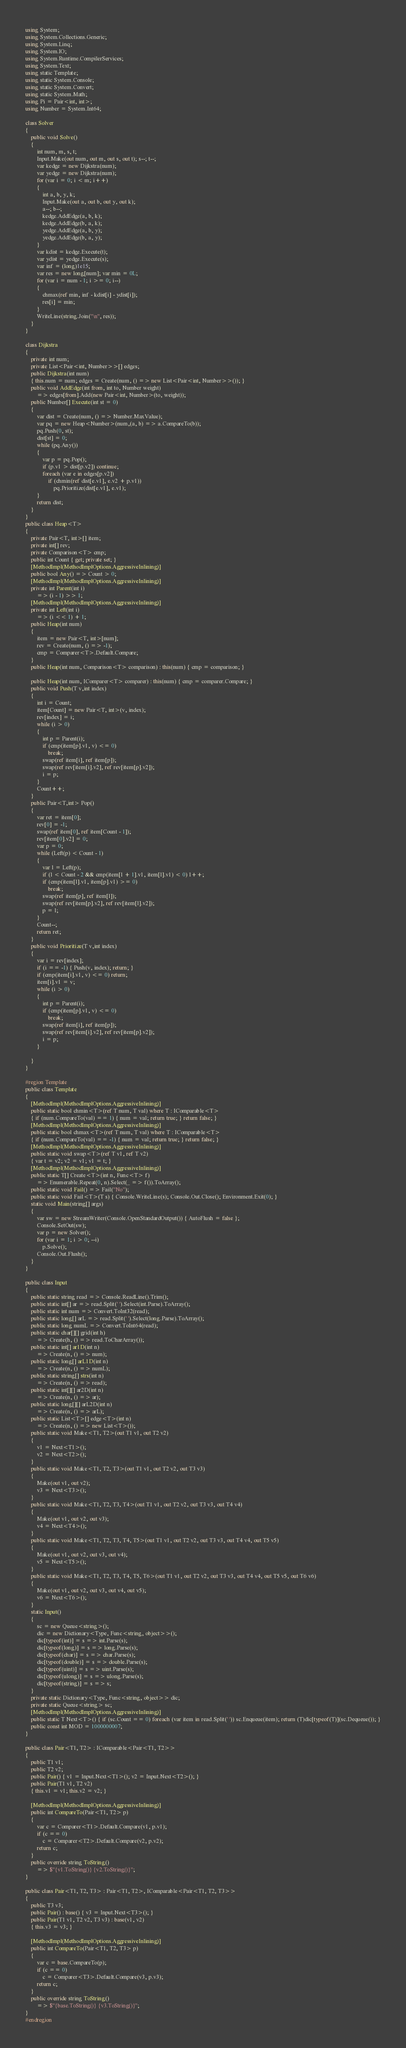<code> <loc_0><loc_0><loc_500><loc_500><_C#_>using System;
using System.Collections.Generic;
using System.Linq;
using System.IO;
using System.Runtime.CompilerServices;
using System.Text;
using static Template;
using static System.Console;
using static System.Convert;
using static System.Math;
using Pi = Pair<int, int>;
using Number = System.Int64;

class Solver
{
    public void Solve()
    {
        int num, m, s, t;
        Input.Make(out num, out m, out s, out t); s--; t--;
        var kedge = new Dijkstra(num);
        var yedge = new Dijkstra(num);
        for (var i = 0; i < m; i++)
        {
            int a, b, y, k;
            Input.Make(out a, out b, out y, out k);
            a--; b--;
            kedge.AddEdge(a, b, k);
            kedge.AddEdge(b, a, k);
            yedge.AddEdge(a, b, y);
            yedge.AddEdge(b, a, y);
        }
        var kdist = kedge.Execute(t);
        var ydist = yedge.Execute(s);
        var inf = (long)1e15;
        var res = new long[num]; var min = 0L;
        for (var i = num - 1; i >= 0; i--)
        {
            chmax(ref min, inf - kdist[i] - ydist[i]);
            res[i] = min;
        }
        WriteLine(string.Join("\n", res));
    }
}

class Dijkstra
{
    private int num;
    private List<Pair<int, Number>>[] edges;
    public Dijkstra(int num)
    { this.num = num; edges = Create(num, () => new List<Pair<int, Number>>()); }
    public void AddEdge(int from, int to, Number weight)
        => edges[from].Add(new Pair<int, Number>(to, weight));
    public Number[] Execute(int st = 0)
    {
        var dist = Create(num, () => Number.MaxValue);
        var pq = new Heap<Number>(num,(a, b) => a.CompareTo(b));
        pq.Push(0, st);
        dist[st] = 0;
        while (pq.Any())
        {
            var p = pq.Pop();
            if (p.v1 > dist[p.v2]) continue;
            foreach (var e in edges[p.v2])
                if (chmin(ref dist[e.v1], e.v2 + p.v1))
                    pq.Prioritize(dist[e.v1], e.v1);
        }
        return dist;
    }
}
public class Heap<T>
{
    private Pair<T, int>[] item;
    private int[] rev;
    private Comparison<T> cmp;
    public int Count { get; private set; }
    [MethodImpl(MethodImplOptions.AggressiveInlining)]
    public bool Any() => Count > 0;
    [MethodImpl(MethodImplOptions.AggressiveInlining)]
    private int Parent(int i)
        => (i - 1) >> 1;
    [MethodImpl(MethodImplOptions.AggressiveInlining)]
    private int Left(int i)
        => (i << 1) + 1;
    public Heap(int num)
    {
        item = new Pair<T, int>[num];
        rev = Create(num, () => -1);
        cmp = Comparer<T>.Default.Compare;
    }
    public Heap(int num, Comparison<T> comparison) : this(num) { cmp = comparison; }

    public Heap(int num, IComparer<T> comparer) : this(num) { cmp = comparer.Compare; }
    public void Push(T v,int index)
    {
        int i = Count;
        item[Count] = new Pair<T, int>(v, index);
        rev[index] = i;
        while (i > 0)
        {
            int p = Parent(i);
            if (cmp(item[p].v1, v) <= 0)
                break;
            swap(ref item[i], ref item[p]);
            swap(ref rev[item[i].v2], ref rev[item[p].v2]);
            i = p;
        }
        Count++;
    }
    public Pair<T,int> Pop()
    {
        var ret = item[0];
        rev[0] = -1;
        swap(ref item[0], ref item[Count - 1]);
        rev[item[0].v2] = 0;
        var p = 0;
        while (Left(p) < Count - 1)
        {
            var l = Left(p);
            if (l < Count - 2 && cmp(item[l + 1].v1, item[l].v1) < 0) l++;
            if (cmp(item[l].v1, item[p].v1) >= 0)
                break;
            swap(ref item[p], ref item[l]);
            swap(ref rev[item[p].v2], ref rev[item[l].v2]);
            p = l;
        }
        Count--;
        return ret;
    }
    public void Prioritize(T v,int index)
    {
        var i = rev[index];
        if (i == -1) { Push(v, index); return; }
        if (cmp(item[i].v1, v) <= 0) return;
        item[i].v1 = v;
        while (i > 0)
        {
            int p = Parent(i);
            if (cmp(item[p].v1, v) <= 0)
                break;
            swap(ref item[i], ref item[p]);
            swap(ref rev[item[i].v2], ref rev[item[p].v2]);
            i = p;
        }

    }
}

#region Template
public class Template
{
    [MethodImpl(MethodImplOptions.AggressiveInlining)]
    public static bool chmin<T>(ref T num, T val) where T : IComparable<T>
    { if (num.CompareTo(val) == 1) { num = val; return true; } return false; }
    [MethodImpl(MethodImplOptions.AggressiveInlining)]
    public static bool chmax<T>(ref T num, T val) where T : IComparable<T>
    { if (num.CompareTo(val) == -1) { num = val; return true; } return false; }
    [MethodImpl(MethodImplOptions.AggressiveInlining)]
    public static void swap<T>(ref T v1, ref T v2)
    { var t = v2; v2 = v1; v1 = t; }
    [MethodImpl(MethodImplOptions.AggressiveInlining)]
    public static T[] Create<T>(int n, Func<T> f)
        => Enumerable.Repeat(0, n).Select(_ => f()).ToArray();
    public static void Fail() => Fail("No");
    public static void Fail<T>(T s) { Console.WriteLine(s); Console.Out.Close(); Environment.Exit(0); }
    static void Main(string[] args)
    {
        var sw = new StreamWriter(Console.OpenStandardOutput()) { AutoFlush = false };
        Console.SetOut(sw);
        var p = new Solver();
        for (var i = 1; i > 0; --i)
            p.Solve();
        Console.Out.Flush();
    }
}

public class Input
{
    public static string read => Console.ReadLine().Trim();
    public static int[] ar => read.Split(' ').Select(int.Parse).ToArray();
    public static int num => Convert.ToInt32(read);
    public static long[] arL => read.Split(' ').Select(long.Parse).ToArray();
    public static long numL => Convert.ToInt64(read);
    public static char[][] grid(int h)
        => Create(h, () => read.ToCharArray());
    public static int[] ar1D(int n)
        => Create(n, () => num);
    public static long[] arL1D(int n)
        => Create(n, () => numL);
    public static string[] strs(int n)
        => Create(n, () => read);
    public static int[][] ar2D(int n)
        => Create(n, () => ar);
    public static long[][] arL2D(int n)
        => Create(n, () => arL);
    public static List<T>[] edge<T>(int n)
        => Create(n, () => new List<T>());
    public static void Make<T1, T2>(out T1 v1, out T2 v2)
    {
        v1 = Next<T1>();
        v2 = Next<T2>();
    }
    public static void Make<T1, T2, T3>(out T1 v1, out T2 v2, out T3 v3)
    {
        Make(out v1, out v2);
        v3 = Next<T3>();
    }
    public static void Make<T1, T2, T3, T4>(out T1 v1, out T2 v2, out T3 v3, out T4 v4)
    {
        Make(out v1, out v2, out v3);
        v4 = Next<T4>();
    }
    public static void Make<T1, T2, T3, T4, T5>(out T1 v1, out T2 v2, out T3 v3, out T4 v4, out T5 v5)
    {
        Make(out v1, out v2, out v3, out v4);
        v5 = Next<T5>();
    }
    public static void Make<T1, T2, T3, T4, T5, T6>(out T1 v1, out T2 v2, out T3 v3, out T4 v4, out T5 v5, out T6 v6)
    {
        Make(out v1, out v2, out v3, out v4, out v5);
        v6 = Next<T6>();
    }
    static Input()
    {
        sc = new Queue<string>();
        dic = new Dictionary<Type, Func<string, object>>();
        dic[typeof(int)] = s => int.Parse(s);
        dic[typeof(long)] = s => long.Parse(s);
        dic[typeof(char)] = s => char.Parse(s);
        dic[typeof(double)] = s => double.Parse(s);
        dic[typeof(uint)] = s => uint.Parse(s);
        dic[typeof(ulong)] = s => ulong.Parse(s);
        dic[typeof(string)] = s => s;
    }
    private static Dictionary<Type, Func<string, object>> dic;
    private static Queue<string> sc;
    [MethodImpl(MethodImplOptions.AggressiveInlining)]
    public static T Next<T>() { if (sc.Count == 0) foreach (var item in read.Split(' ')) sc.Enqueue(item); return (T)dic[typeof(T)](sc.Dequeue()); }
    public const int MOD = 1000000007;
}

public class Pair<T1, T2> : IComparable<Pair<T1, T2>>
{
    public T1 v1;
    public T2 v2;
    public Pair() { v1 = Input.Next<T1>(); v2 = Input.Next<T2>(); }
    public Pair(T1 v1, T2 v2)
    { this.v1 = v1; this.v2 = v2; }

    [MethodImpl(MethodImplOptions.AggressiveInlining)]
    public int CompareTo(Pair<T1, T2> p)
    {
        var c = Comparer<T1>.Default.Compare(v1, p.v1);
        if (c == 0)
            c = Comparer<T2>.Default.Compare(v2, p.v2);
        return c;
    }
    public override string ToString()
        => $"{v1.ToString()} {v2.ToString()}";
}

public class Pair<T1, T2, T3> : Pair<T1, T2>, IComparable<Pair<T1, T2, T3>>
{
    public T3 v3;
    public Pair() : base() { v3 = Input.Next<T3>(); }
    public Pair(T1 v1, T2 v2, T3 v3) : base(v1, v2)
    { this.v3 = v3; }

    [MethodImpl(MethodImplOptions.AggressiveInlining)]
    public int CompareTo(Pair<T1, T2, T3> p)
    {
        var c = base.CompareTo(p);
        if (c == 0)
            c = Comparer<T3>.Default.Compare(v3, p.v3);
        return c;
    }
    public override string ToString()
        => $"{base.ToString()} {v3.ToString()}";
}
#endregion
</code> 